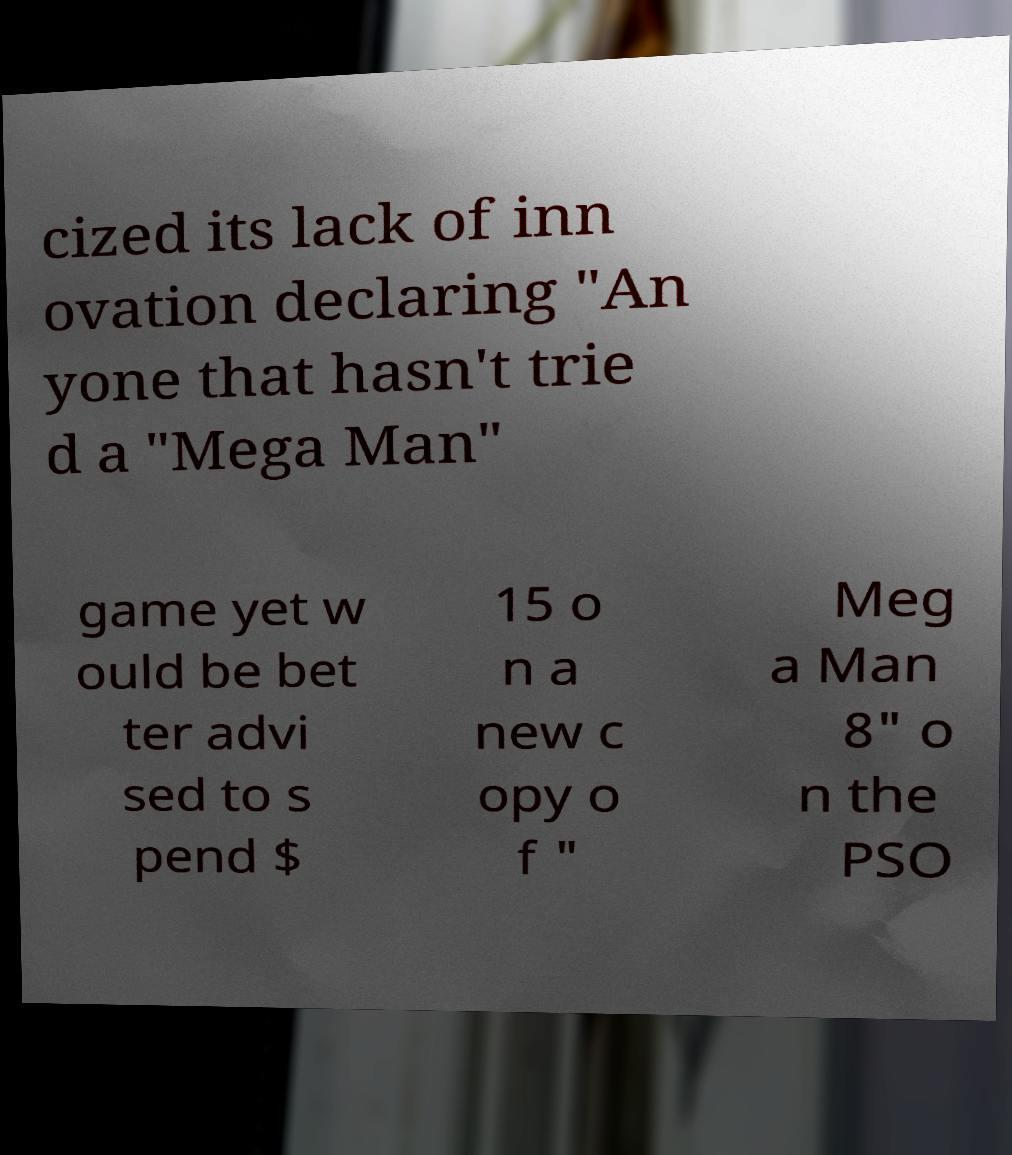What messages or text are displayed in this image? I need them in a readable, typed format. cized its lack of inn ovation declaring "An yone that hasn't trie d a "Mega Man" game yet w ould be bet ter advi sed to s pend $ 15 o n a new c opy o f " Meg a Man 8" o n the PSO 